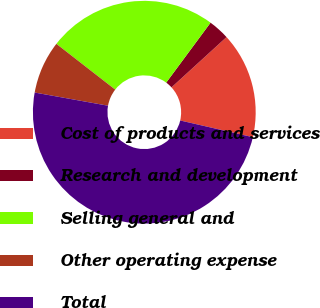<chart> <loc_0><loc_0><loc_500><loc_500><pie_chart><fcel>Cost of products and services<fcel>Research and development<fcel>Selling general and<fcel>Other operating expense<fcel>Total<nl><fcel>15.38%<fcel>3.08%<fcel>24.62%<fcel>7.69%<fcel>49.23%<nl></chart> 